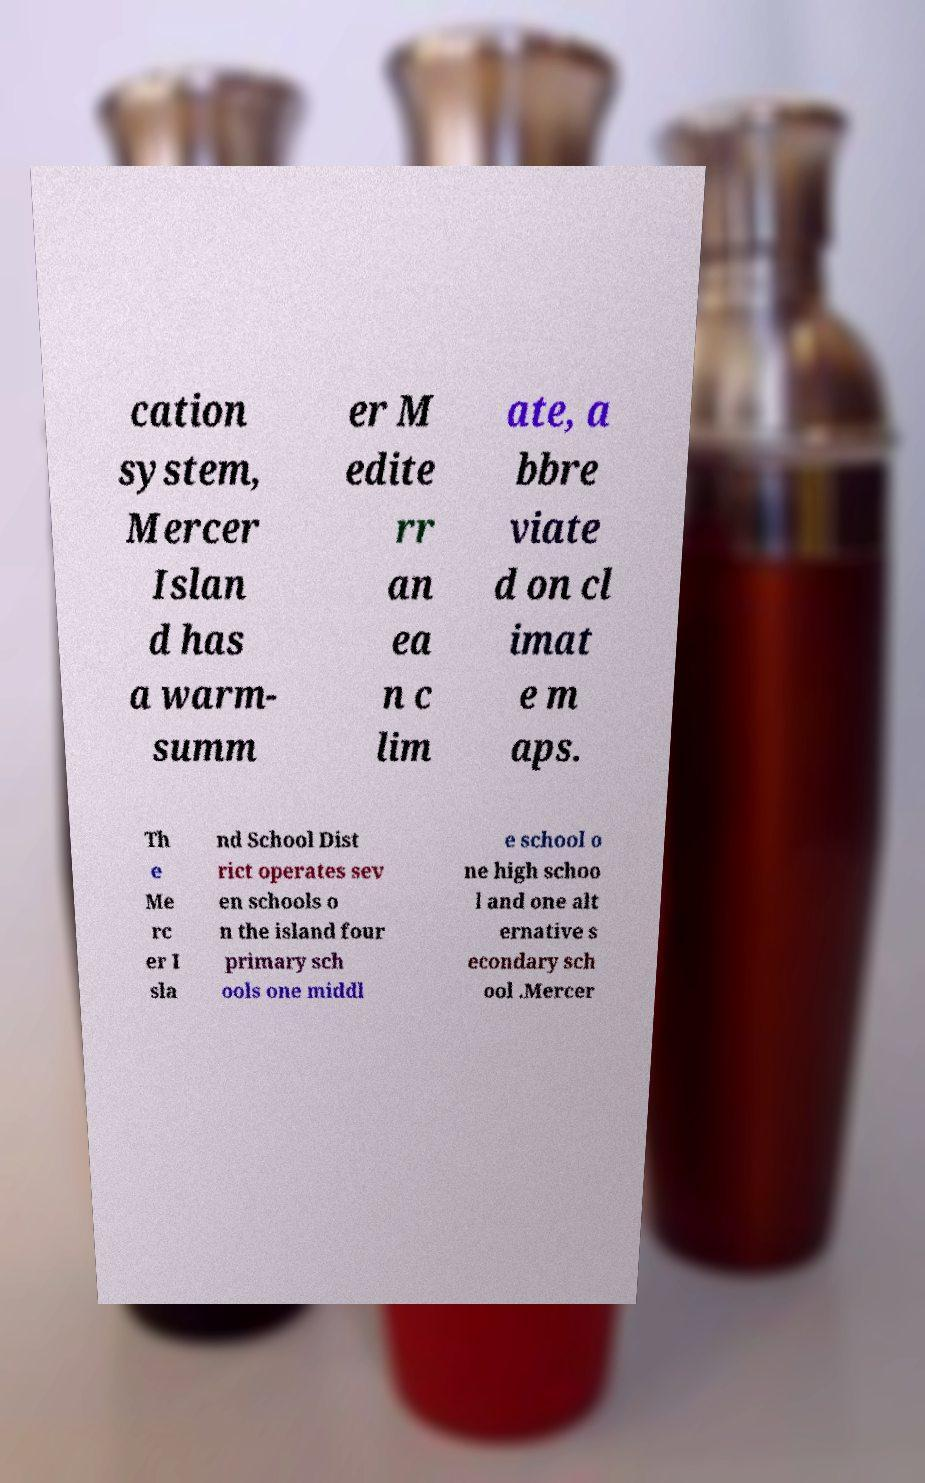I need the written content from this picture converted into text. Can you do that? cation system, Mercer Islan d has a warm- summ er M edite rr an ea n c lim ate, a bbre viate d on cl imat e m aps. Th e Me rc er I sla nd School Dist rict operates sev en schools o n the island four primary sch ools one middl e school o ne high schoo l and one alt ernative s econdary sch ool .Mercer 